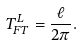Convert formula to latex. <formula><loc_0><loc_0><loc_500><loc_500>T ^ { L } _ { F T } = \frac { \ell } { 2 \pi } .</formula> 